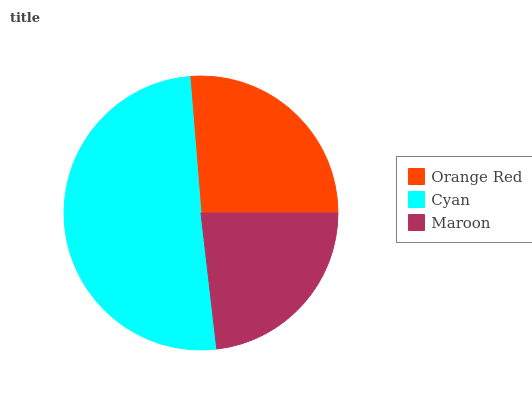Is Maroon the minimum?
Answer yes or no. Yes. Is Cyan the maximum?
Answer yes or no. Yes. Is Cyan the minimum?
Answer yes or no. No. Is Maroon the maximum?
Answer yes or no. No. Is Cyan greater than Maroon?
Answer yes or no. Yes. Is Maroon less than Cyan?
Answer yes or no. Yes. Is Maroon greater than Cyan?
Answer yes or no. No. Is Cyan less than Maroon?
Answer yes or no. No. Is Orange Red the high median?
Answer yes or no. Yes. Is Orange Red the low median?
Answer yes or no. Yes. Is Cyan the high median?
Answer yes or no. No. Is Cyan the low median?
Answer yes or no. No. 